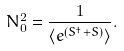Convert formula to latex. <formula><loc_0><loc_0><loc_500><loc_500>N ^ { 2 } _ { 0 } = \frac { 1 } { \langle e ^ { ( S ^ { \dagger } + S ) } \rangle } .</formula> 